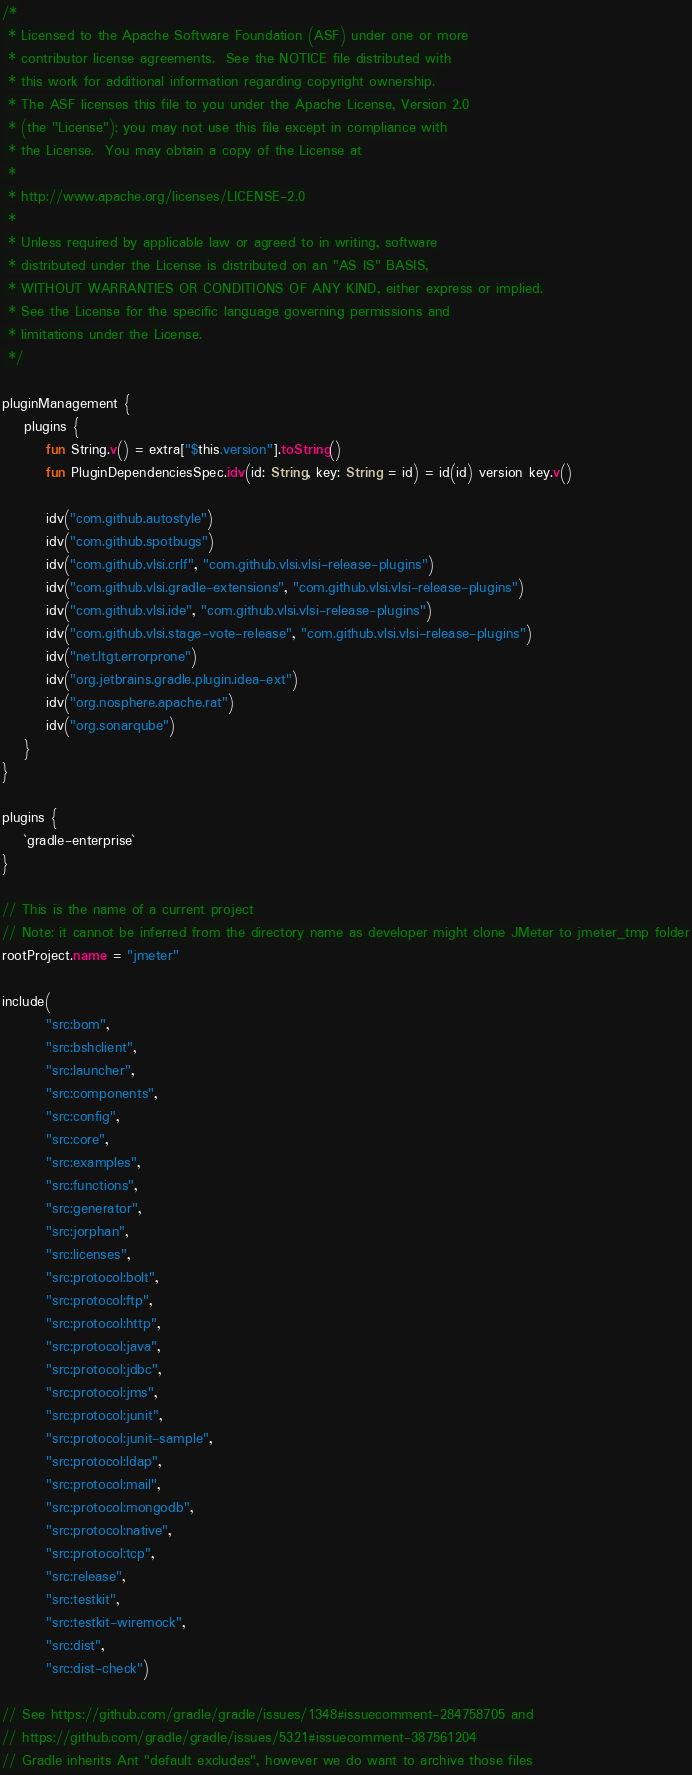Convert code to text. <code><loc_0><loc_0><loc_500><loc_500><_Kotlin_>/*
 * Licensed to the Apache Software Foundation (ASF) under one or more
 * contributor license agreements.  See the NOTICE file distributed with
 * this work for additional information regarding copyright ownership.
 * The ASF licenses this file to you under the Apache License, Version 2.0
 * (the "License"); you may not use this file except in compliance with
 * the License.  You may obtain a copy of the License at
 *
 * http://www.apache.org/licenses/LICENSE-2.0
 *
 * Unless required by applicable law or agreed to in writing, software
 * distributed under the License is distributed on an "AS IS" BASIS,
 * WITHOUT WARRANTIES OR CONDITIONS OF ANY KIND, either express or implied.
 * See the License for the specific language governing permissions and
 * limitations under the License.
 */

pluginManagement {
    plugins {
        fun String.v() = extra["$this.version"].toString()
        fun PluginDependenciesSpec.idv(id: String, key: String = id) = id(id) version key.v()

        idv("com.github.autostyle")
        idv("com.github.spotbugs")
        idv("com.github.vlsi.crlf", "com.github.vlsi.vlsi-release-plugins")
        idv("com.github.vlsi.gradle-extensions", "com.github.vlsi.vlsi-release-plugins")
        idv("com.github.vlsi.ide", "com.github.vlsi.vlsi-release-plugins")
        idv("com.github.vlsi.stage-vote-release", "com.github.vlsi.vlsi-release-plugins")
        idv("net.ltgt.errorprone")
        idv("org.jetbrains.gradle.plugin.idea-ext")
        idv("org.nosphere.apache.rat")
        idv("org.sonarqube")
    }
}

plugins {
    `gradle-enterprise`
}

// This is the name of a current project
// Note: it cannot be inferred from the directory name as developer might clone JMeter to jmeter_tmp folder
rootProject.name = "jmeter"

include(
        "src:bom",
        "src:bshclient",
        "src:launcher",
        "src:components",
        "src:config",
        "src:core",
        "src:examples",
        "src:functions",
        "src:generator",
        "src:jorphan",
        "src:licenses",
        "src:protocol:bolt",
        "src:protocol:ftp",
        "src:protocol:http",
        "src:protocol:java",
        "src:protocol:jdbc",
        "src:protocol:jms",
        "src:protocol:junit",
        "src:protocol:junit-sample",
        "src:protocol:ldap",
        "src:protocol:mail",
        "src:protocol:mongodb",
        "src:protocol:native",
        "src:protocol:tcp",
        "src:release",
        "src:testkit",
        "src:testkit-wiremock",
        "src:dist",
        "src:dist-check")

// See https://github.com/gradle/gradle/issues/1348#issuecomment-284758705 and
// https://github.com/gradle/gradle/issues/5321#issuecomment-387561204
// Gradle inherits Ant "default excludes", however we do want to archive those files</code> 